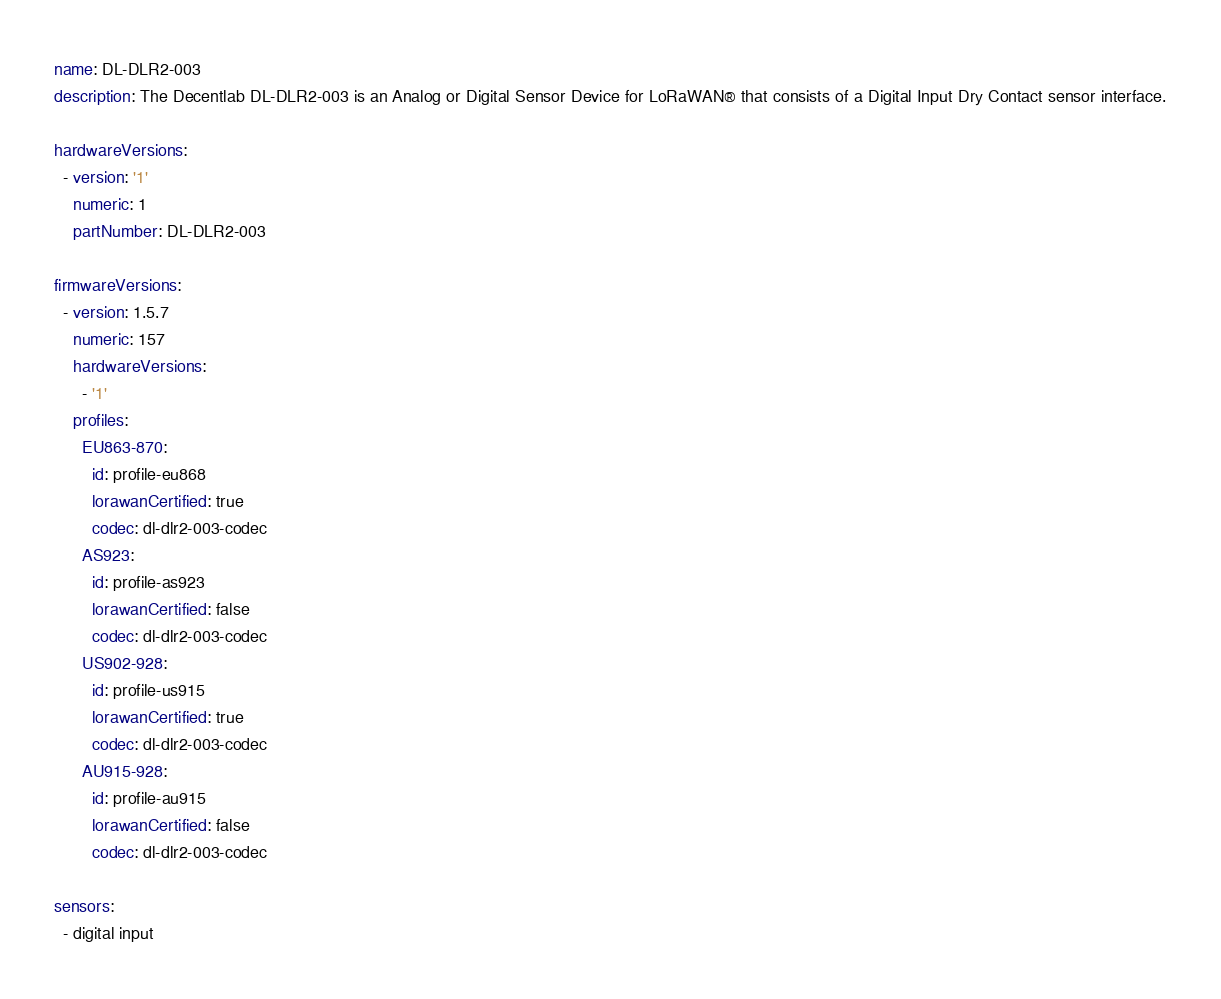Convert code to text. <code><loc_0><loc_0><loc_500><loc_500><_YAML_>name: DL-DLR2-003
description: The Decentlab DL-DLR2-003 is an Analog or Digital Sensor Device for LoRaWAN® that consists of a Digital Input Dry Contact sensor interface.

hardwareVersions:
  - version: '1'
    numeric: 1
    partNumber: DL-DLR2-003

firmwareVersions:
  - version: 1.5.7
    numeric: 157
    hardwareVersions:
      - '1'
    profiles:
      EU863-870:
        id: profile-eu868
        lorawanCertified: true
        codec: dl-dlr2-003-codec
      AS923:
        id: profile-as923
        lorawanCertified: false
        codec: dl-dlr2-003-codec
      US902-928:
        id: profile-us915
        lorawanCertified: true
        codec: dl-dlr2-003-codec
      AU915-928:
        id: profile-au915
        lorawanCertified: false
        codec: dl-dlr2-003-codec

sensors:
  - digital input</code> 